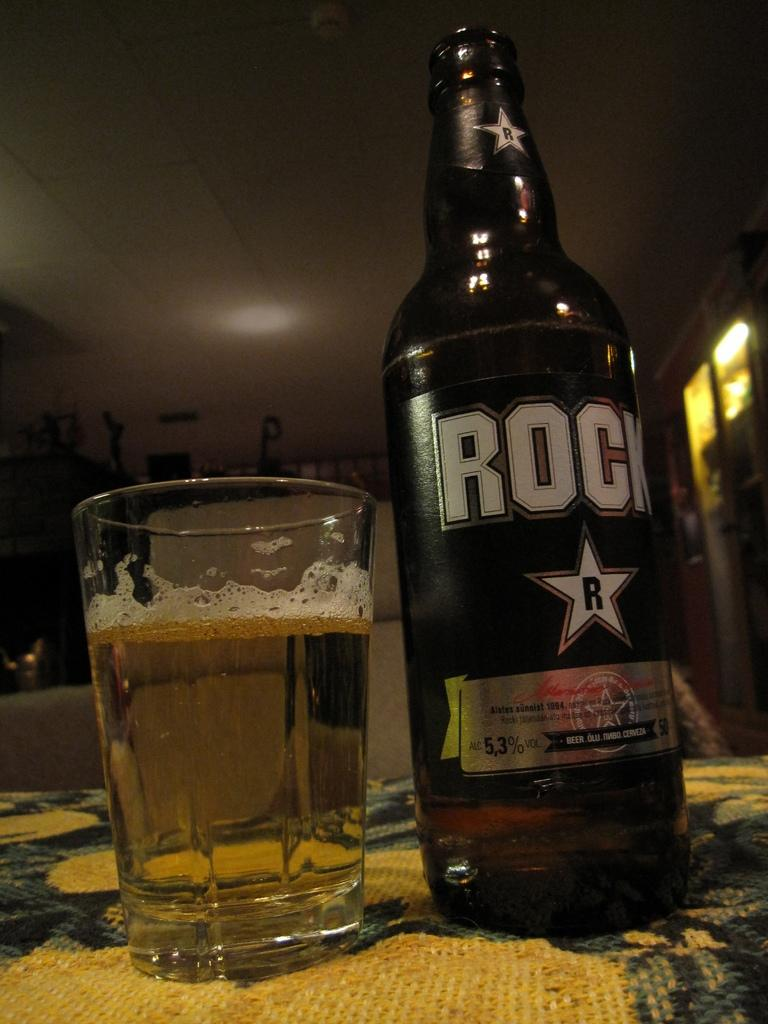<image>
Share a concise interpretation of the image provided. A full glass next to a bottle of Rock beer 